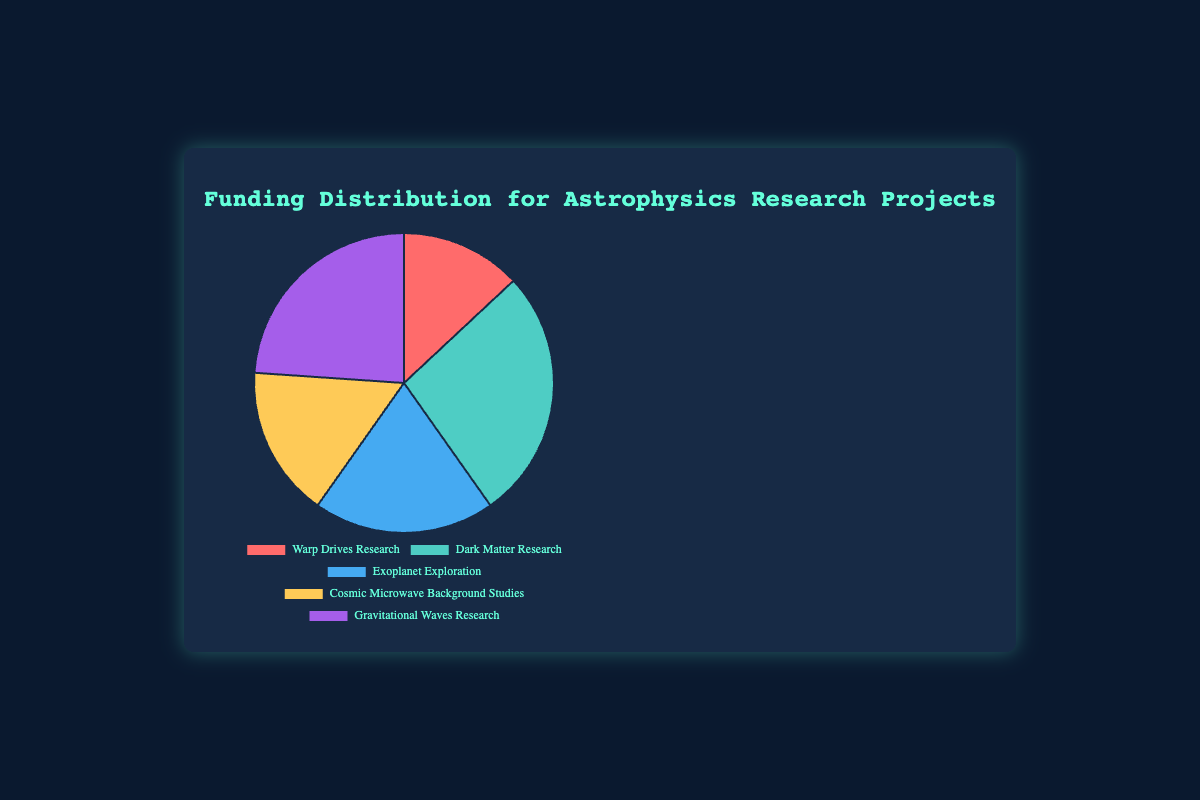What is the largest allocation of funding in the chart? The "Dark Matter Research" section is the largest in size and represents the highest funding, with $25,000,000.
Answer: Dark Matter Research Which research project received the smallest amount of funding? The smallest slice of the pie chart corresponds to "Warp Drives Research," which received $12,000,000.
Answer: Warp Drives Research What is the total funding represented in the pie chart? Add the amounts of all five projects: $12,000,000 + $25,000,000 + $18,000,000 + $15,000,000 + $22,000,000 = $92,000,000
Answer: $92,000,000 How much more funding did Exoplanet Exploration receive compared to Cosmic Microwave Background Studies? Subtract the funding for Cosmic Microwave Background Studies from Exoplanet Exploration: $18,000,000 - $15,000,000 = $3,000,000
Answer: $3,000,000 Which two projects combined have more funding than Gravitational Waves Research? Adding "Exoplanet Exploration" and "Cosmic Microwave Background Studies": $18,000,000 + $15,000,000 = $33,000,000, which is more than $22,000,000 (Gravitational Waves Research).
Answer: Exoplanet Exploration and Cosmic Microwave Background Studies What percentage of the total funding is devoted to Gravitational Waves Research? Divide the Gravitational Waves Research funding by the total funding and multiply by 100: ($22,000,000 / $92,000,000) * 100 ≈ 23.91%
Answer: 23.91% If the funding was redistributed equally among all five projects, how much funding would each project receive? Divide the total funding by 5: $92,000,000 / 5 = $18,400,000
Answer: $18,400,000 How much less funding did Warp Drives Research receive compared to Dark Matter Research? Subtract Warp Drives Research funding from Dark Matter Research: $25,000,000 - $12,000,000 = $13,000,000
Answer: $13,000,000 What is the average funding per project? Divide the total funding by the number of projects: $92,000,000 / 5 = $18,400,000
Answer: $18,400,000 